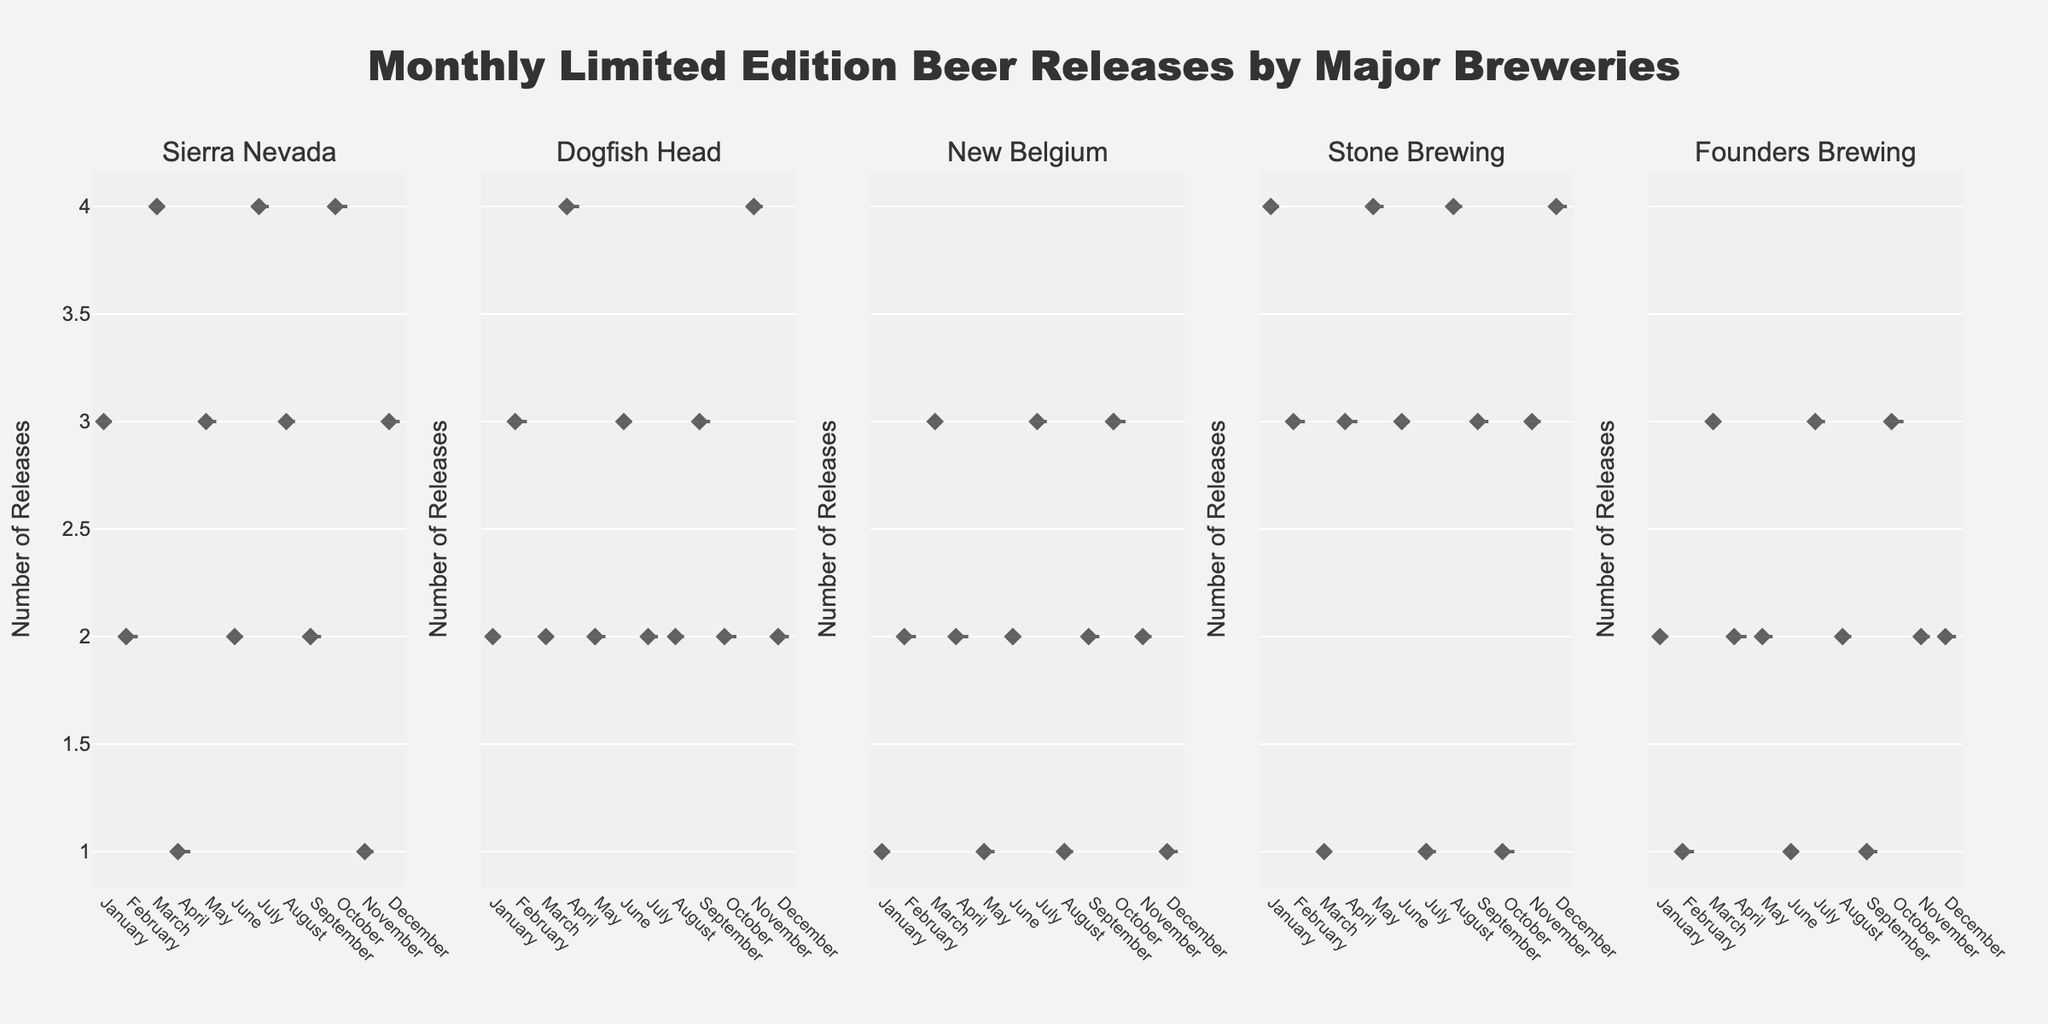What's the title of the figure? The title is typically positioned at the top of the figure. In this case, it states, "Monthly Limited Edition Beer Releases by Major Breweries".
Answer: Monthly Limited Edition Beer Releases by Major Breweries How many breweries are included in the analysis? Look at the subplot titles representing each brewery. There are five distinct titles, suggesting five breweries are analyzed.
Answer: Five Which brewery has the highest number of releases in January? Observe the violin plot for January and note the point on the y-axis where the number of releases is the highest across the breweries. Stone Brewing shows the highest releases with a count of 4.
Answer: Stone Brewing Which brewery shows the most variability in the number of releases across all months? Check each violin plot for the spread of data points. Dogfish Head’s plot appears to have the widest spread (most variation) across months.
Answer: Dogfish Head What's the average number of releases for Sierra Nevada in March and July? Identify the y-axis values for Sierra Nevada in March (4 releases) and July (4 releases). The average would be calculated as (4+4)/2 = 4.
Answer: 4 Compare the median number of releases between Stone Brewing and Founders Brewing. Which one is higher? Look at the median lines on the violin plots of both breweries. Stone Brewing’s median appears higher than Founders Brewing’s.
Answer: Stone Brewing During which month does New Belgium have the lowest median release count? Visually check the median lines within the violin plots for New Belgium. The lowest median count is observed in January, May, August, and December, which all show a median of 1 release.
Answer: January, May, August, December Which month has the highest average number of releases for all breweries combined? Sum up the data points for each month for all breweries and divide by the number of breweries (5). March, July, and October all have higher average values when summed and averaged. Detailed calculations show that October has the highest.
Answer: October What can you infer about the frequency of beer releases in December across breweries? Examine each subplot for December. Most breweries have a low and consistent pattern, showing fewer releases, indicating December might be a less active month for beer releases.
Answer: Consistently low releases Which brewery maintains the most consistent number of releases throughout the year? Look at the spread and interquartile ranges of the violin plots. Sierra Nevada has a pattern with minor variations, showing more consistency year-round.
Answer: Sierra Nevada 